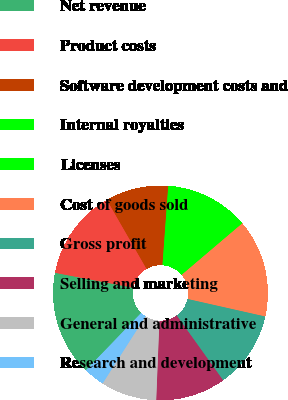<chart> <loc_0><loc_0><loc_500><loc_500><pie_chart><fcel>Net revenue<fcel>Product costs<fcel>Software development costs and<fcel>Internal royalties<fcel>Licenses<fcel>Cost of goods sold<fcel>Gross profit<fcel>Selling and marketing<fcel>General and administrative<fcel>Research and development<nl><fcel>15.79%<fcel>13.68%<fcel>9.47%<fcel>7.37%<fcel>5.26%<fcel>14.74%<fcel>11.58%<fcel>10.53%<fcel>8.42%<fcel>3.16%<nl></chart> 